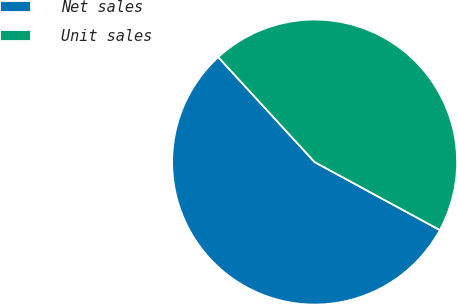Convert chart to OTSL. <chart><loc_0><loc_0><loc_500><loc_500><pie_chart><fcel>Net sales<fcel>Unit sales<nl><fcel>55.26%<fcel>44.74%<nl></chart> 